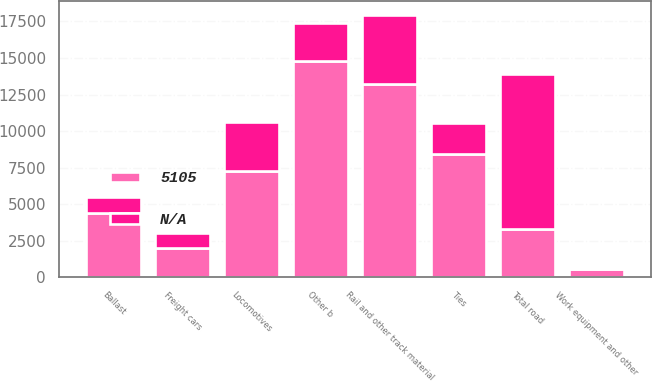Convert chart. <chart><loc_0><loc_0><loc_500><loc_500><stacked_bar_chart><ecel><fcel>Rail and other track material<fcel>Ties<fcel>Ballast<fcel>Other b<fcel>Total road<fcel>Locomotives<fcel>Freight cars<fcel>Work equipment and other<nl><fcel>5105<fcel>13220<fcel>8404<fcel>4399<fcel>14806<fcel>3321<fcel>7297<fcel>1991<fcel>535<nl><fcel>nan<fcel>4756<fcel>2157<fcel>1085<fcel>2583<fcel>10581<fcel>3321<fcel>1018<fcel>89<nl></chart> 